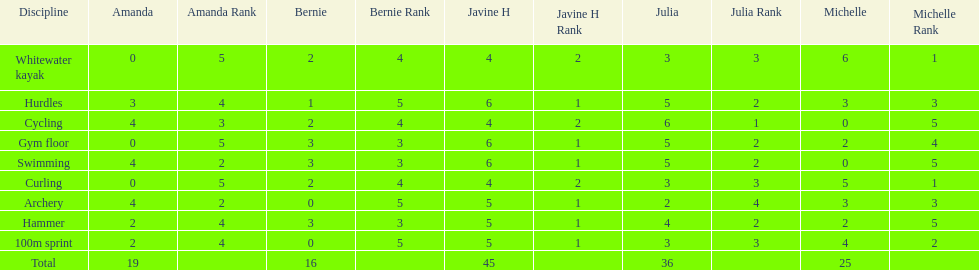What are the number of points bernie scored in hurdles? 1. 